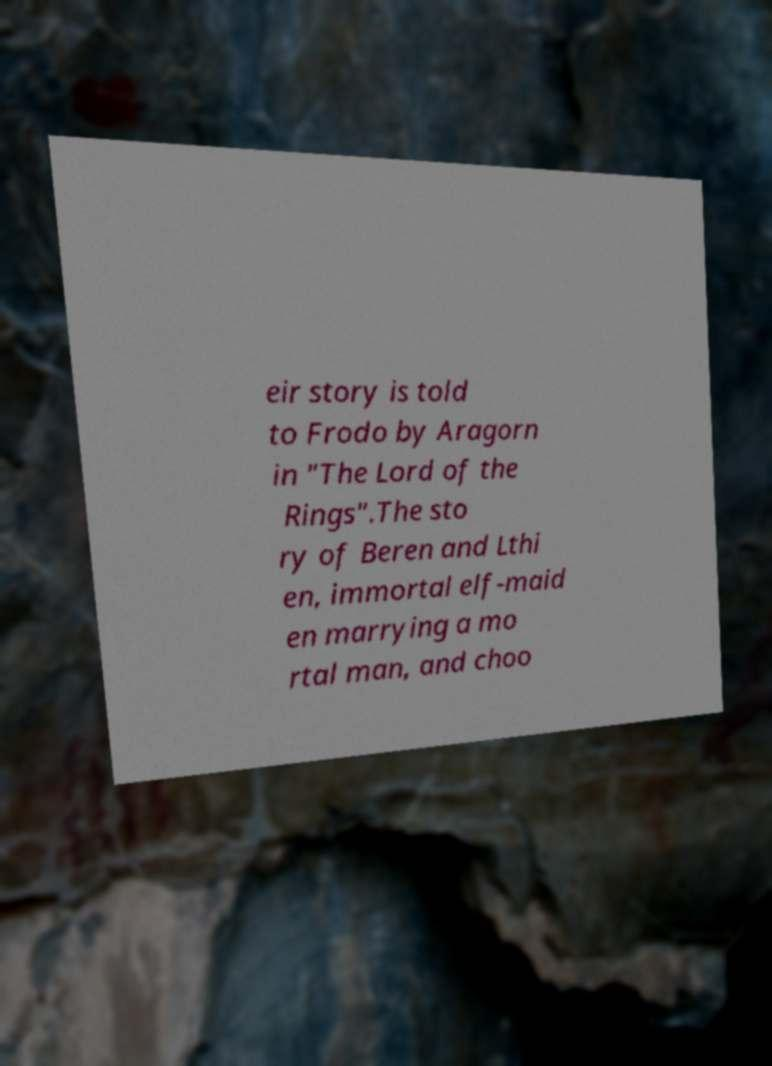There's text embedded in this image that I need extracted. Can you transcribe it verbatim? eir story is told to Frodo by Aragorn in "The Lord of the Rings".The sto ry of Beren and Lthi en, immortal elf-maid en marrying a mo rtal man, and choo 